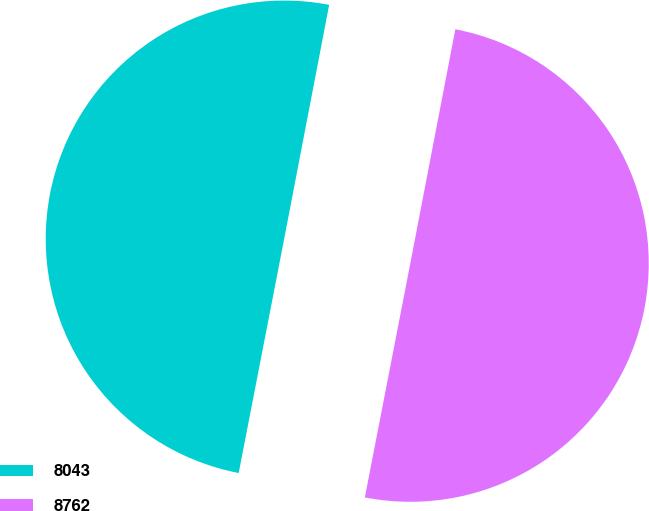<chart> <loc_0><loc_0><loc_500><loc_500><pie_chart><fcel>8043<fcel>8762<nl><fcel>49.97%<fcel>50.03%<nl></chart> 